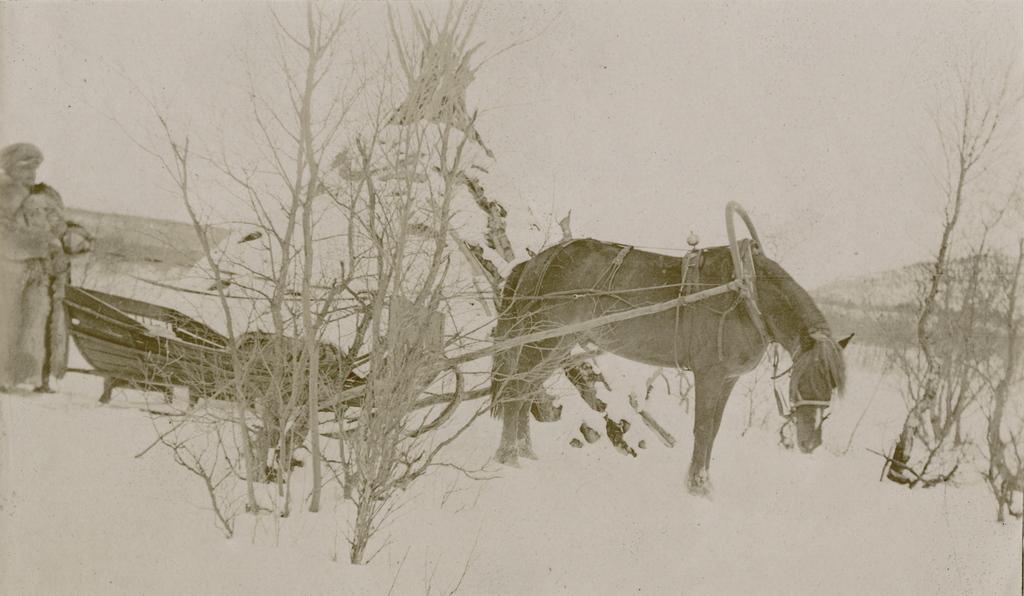Can you describe this image briefly? In the center of the image we can see a horse. On the left there is a person and a cart. In the background there are trees and sky. 